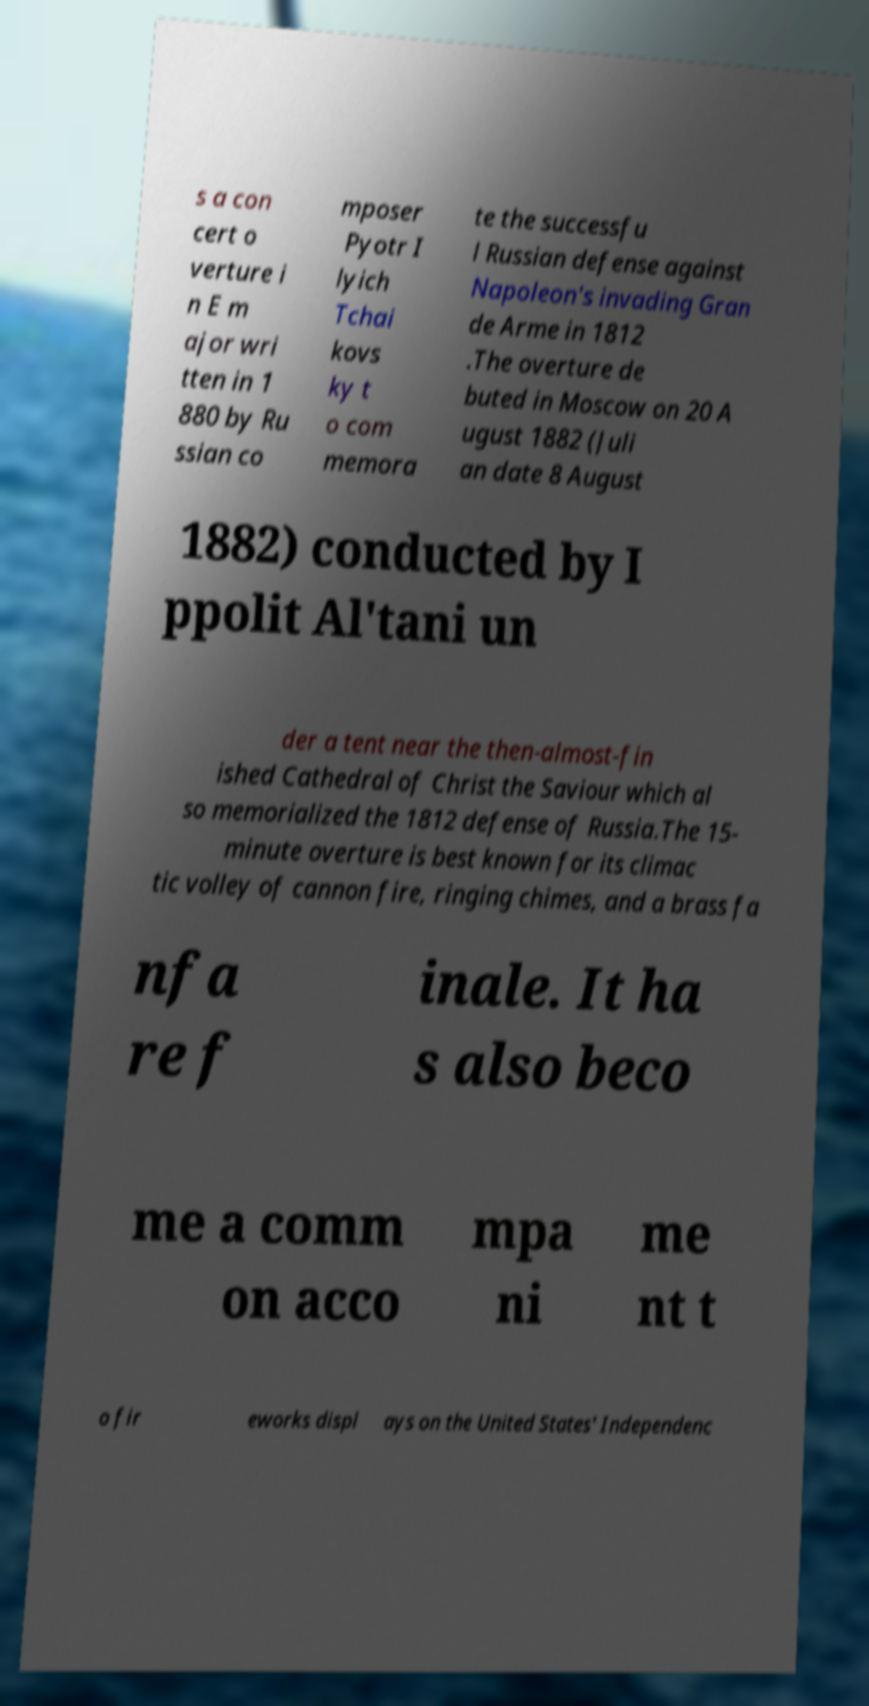Could you assist in decoding the text presented in this image and type it out clearly? s a con cert o verture i n E m ajor wri tten in 1 880 by Ru ssian co mposer Pyotr I lyich Tchai kovs ky t o com memora te the successfu l Russian defense against Napoleon's invading Gran de Arme in 1812 .The overture de buted in Moscow on 20 A ugust 1882 (Juli an date 8 August 1882) conducted by I ppolit Al'tani un der a tent near the then-almost-fin ished Cathedral of Christ the Saviour which al so memorialized the 1812 defense of Russia.The 15- minute overture is best known for its climac tic volley of cannon fire, ringing chimes, and a brass fa nfa re f inale. It ha s also beco me a comm on acco mpa ni me nt t o fir eworks displ ays on the United States' Independenc 